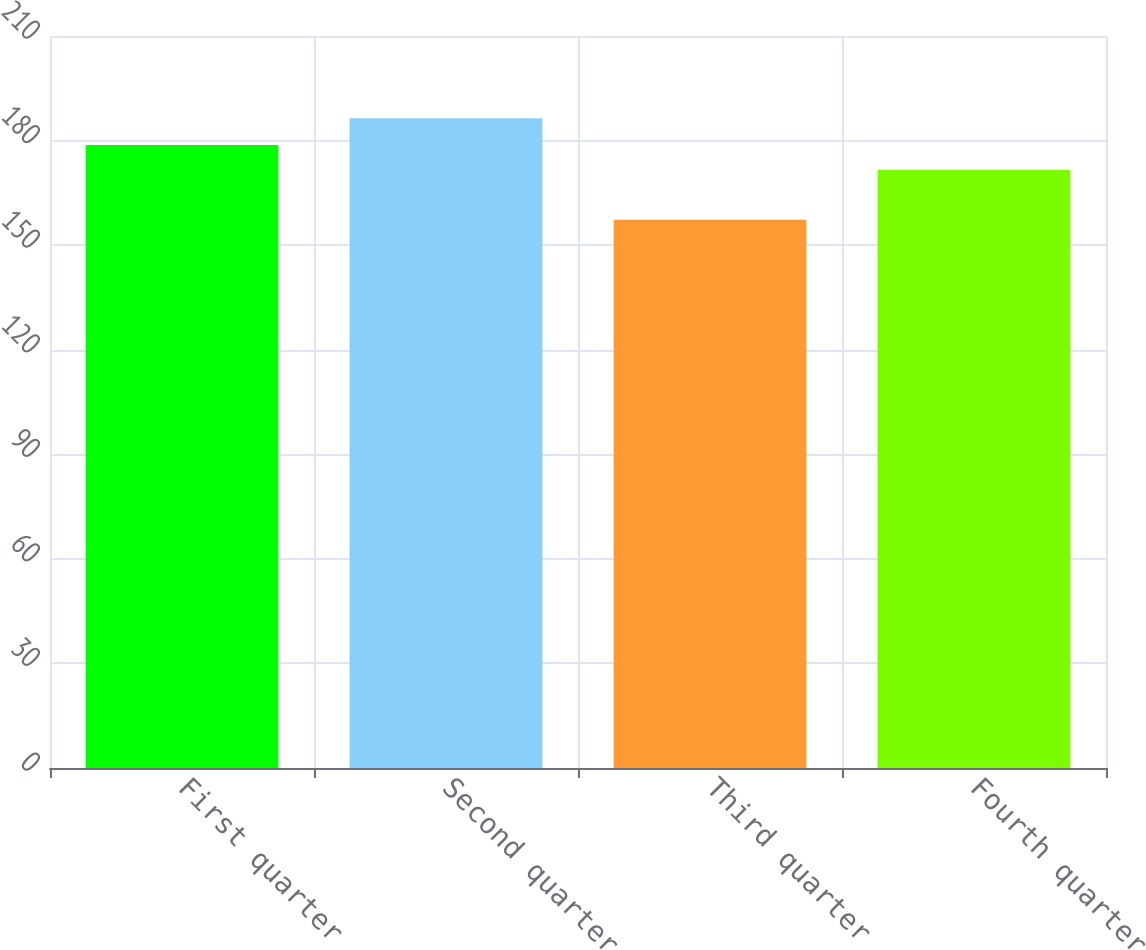Convert chart to OTSL. <chart><loc_0><loc_0><loc_500><loc_500><bar_chart><fcel>First quarter<fcel>Second quarter<fcel>Third quarter<fcel>Fourth quarter<nl><fcel>178.75<fcel>186.41<fcel>157.25<fcel>171.61<nl></chart> 